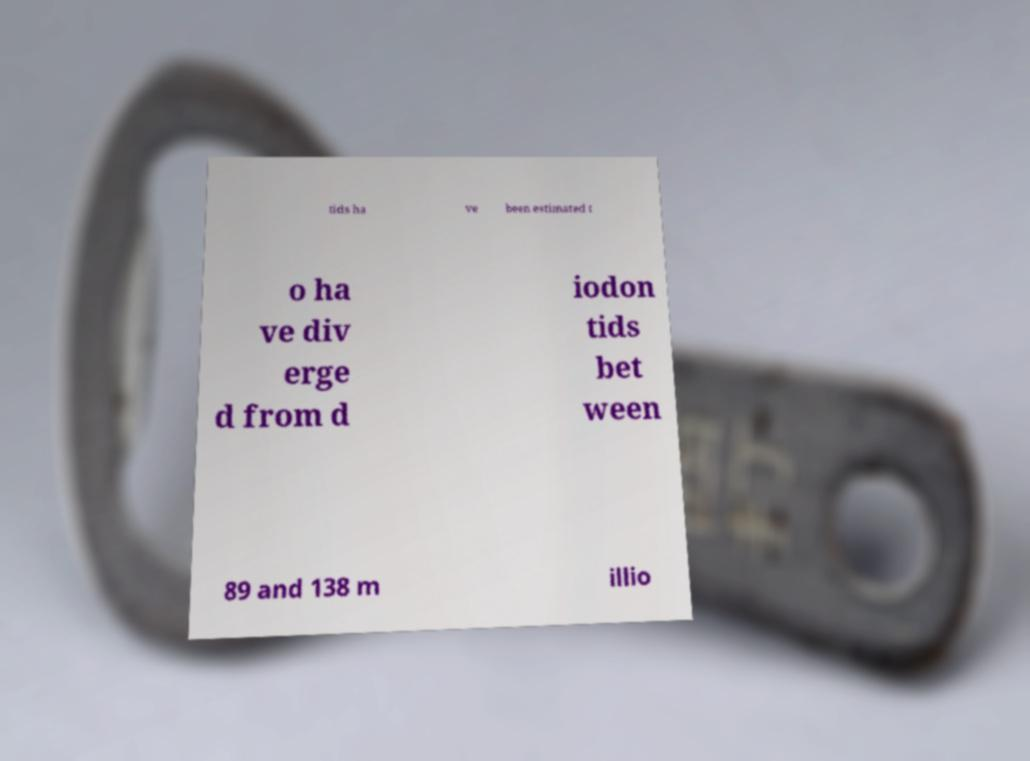Please identify and transcribe the text found in this image. tids ha ve been estimated t o ha ve div erge d from d iodon tids bet ween 89 and 138 m illio 